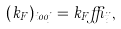Convert formula to latex. <formula><loc_0><loc_0><loc_500><loc_500>( k _ { F } ) _ { i 0 0 j } = k _ { F } \delta _ { i j } ,</formula> 